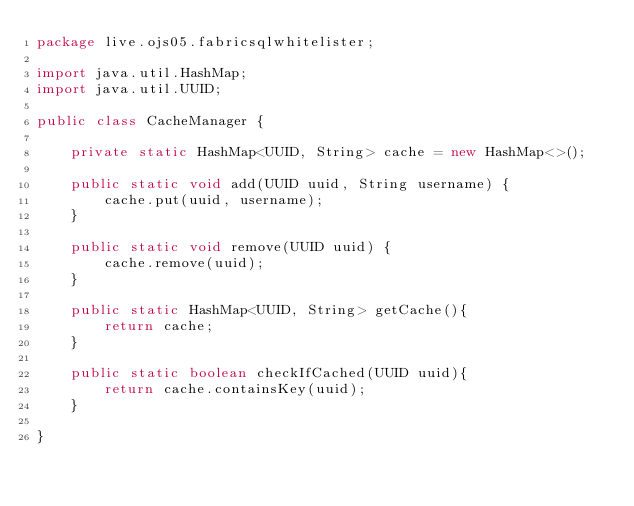Convert code to text. <code><loc_0><loc_0><loc_500><loc_500><_Java_>package live.ojs05.fabricsqlwhitelister;

import java.util.HashMap;
import java.util.UUID;

public class CacheManager {

    private static HashMap<UUID, String> cache = new HashMap<>();

    public static void add(UUID uuid, String username) {
        cache.put(uuid, username);
    }

    public static void remove(UUID uuid) {
        cache.remove(uuid);
    }

    public static HashMap<UUID, String> getCache(){
        return cache;
    }

    public static boolean checkIfCached(UUID uuid){
        return cache.containsKey(uuid);
    }

}
</code> 